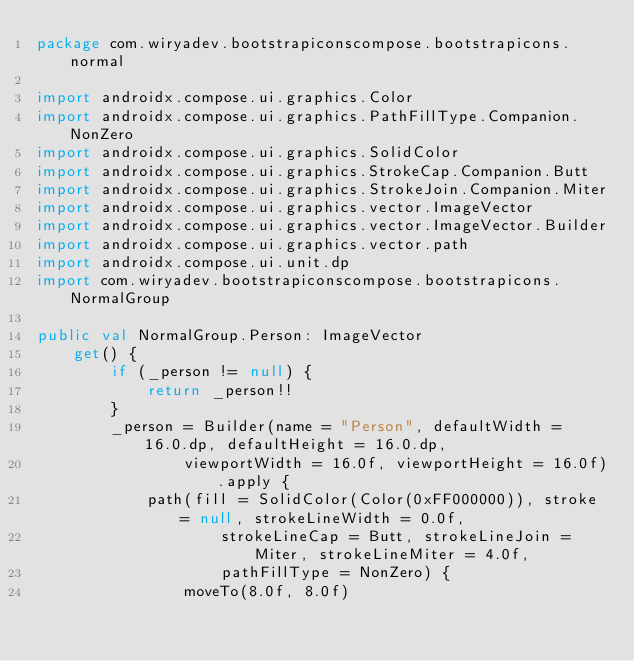<code> <loc_0><loc_0><loc_500><loc_500><_Kotlin_>package com.wiryadev.bootstrapiconscompose.bootstrapicons.normal

import androidx.compose.ui.graphics.Color
import androidx.compose.ui.graphics.PathFillType.Companion.NonZero
import androidx.compose.ui.graphics.SolidColor
import androidx.compose.ui.graphics.StrokeCap.Companion.Butt
import androidx.compose.ui.graphics.StrokeJoin.Companion.Miter
import androidx.compose.ui.graphics.vector.ImageVector
import androidx.compose.ui.graphics.vector.ImageVector.Builder
import androidx.compose.ui.graphics.vector.path
import androidx.compose.ui.unit.dp
import com.wiryadev.bootstrapiconscompose.bootstrapicons.NormalGroup

public val NormalGroup.Person: ImageVector
    get() {
        if (_person != null) {
            return _person!!
        }
        _person = Builder(name = "Person", defaultWidth = 16.0.dp, defaultHeight = 16.0.dp,
                viewportWidth = 16.0f, viewportHeight = 16.0f).apply {
            path(fill = SolidColor(Color(0xFF000000)), stroke = null, strokeLineWidth = 0.0f,
                    strokeLineCap = Butt, strokeLineJoin = Miter, strokeLineMiter = 4.0f,
                    pathFillType = NonZero) {
                moveTo(8.0f, 8.0f)</code> 